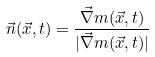Convert formula to latex. <formula><loc_0><loc_0><loc_500><loc_500>\vec { n } ( \vec { x } , t ) = \frac { \vec { \nabla } m ( \vec { x } , t ) } { | \vec { \nabla } m ( \vec { x } , t ) | }</formula> 